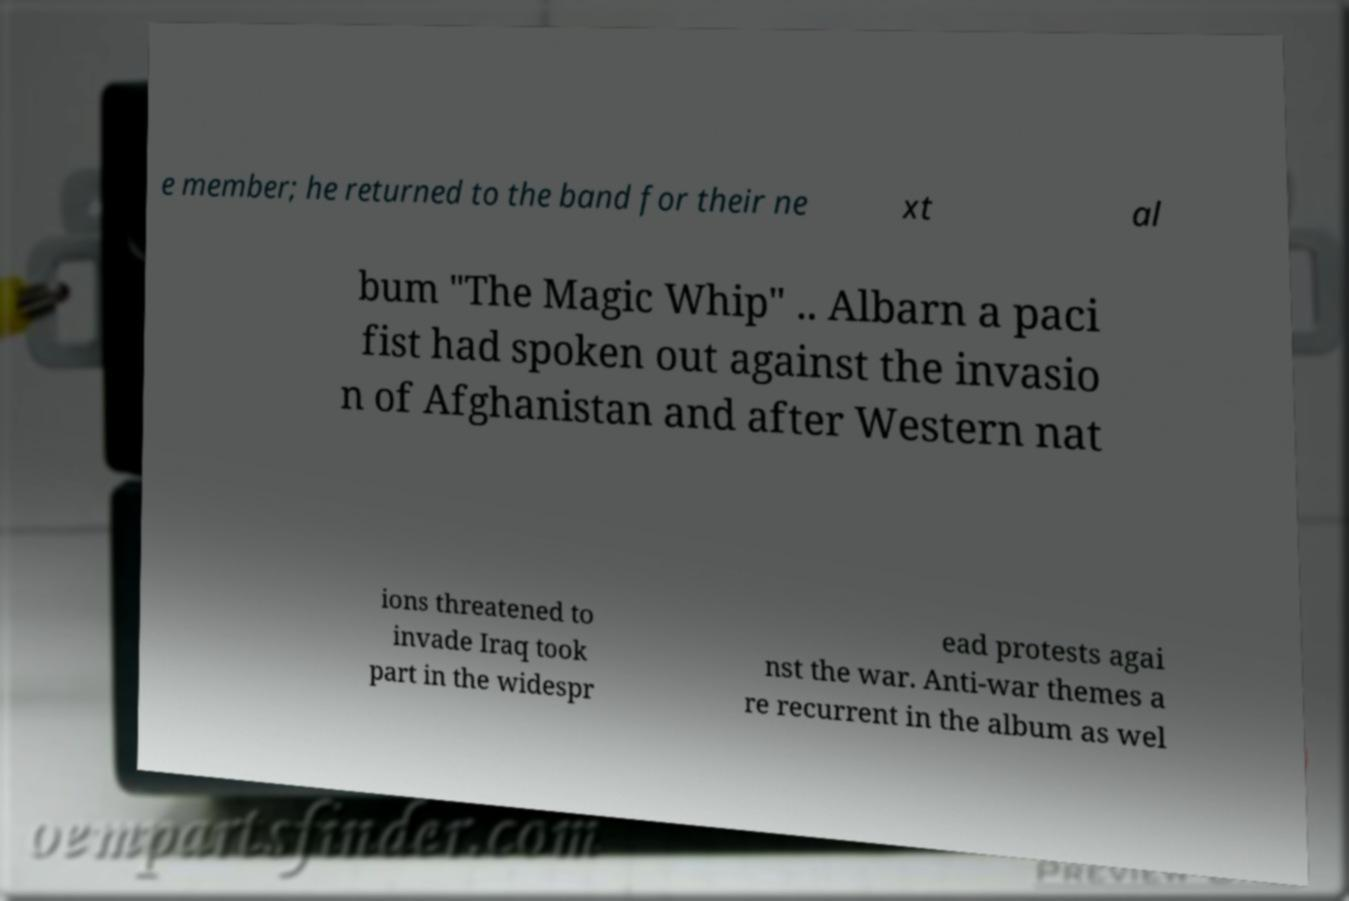I need the written content from this picture converted into text. Can you do that? e member; he returned to the band for their ne xt al bum "The Magic Whip" .. Albarn a paci fist had spoken out against the invasio n of Afghanistan and after Western nat ions threatened to invade Iraq took part in the widespr ead protests agai nst the war. Anti-war themes a re recurrent in the album as wel 